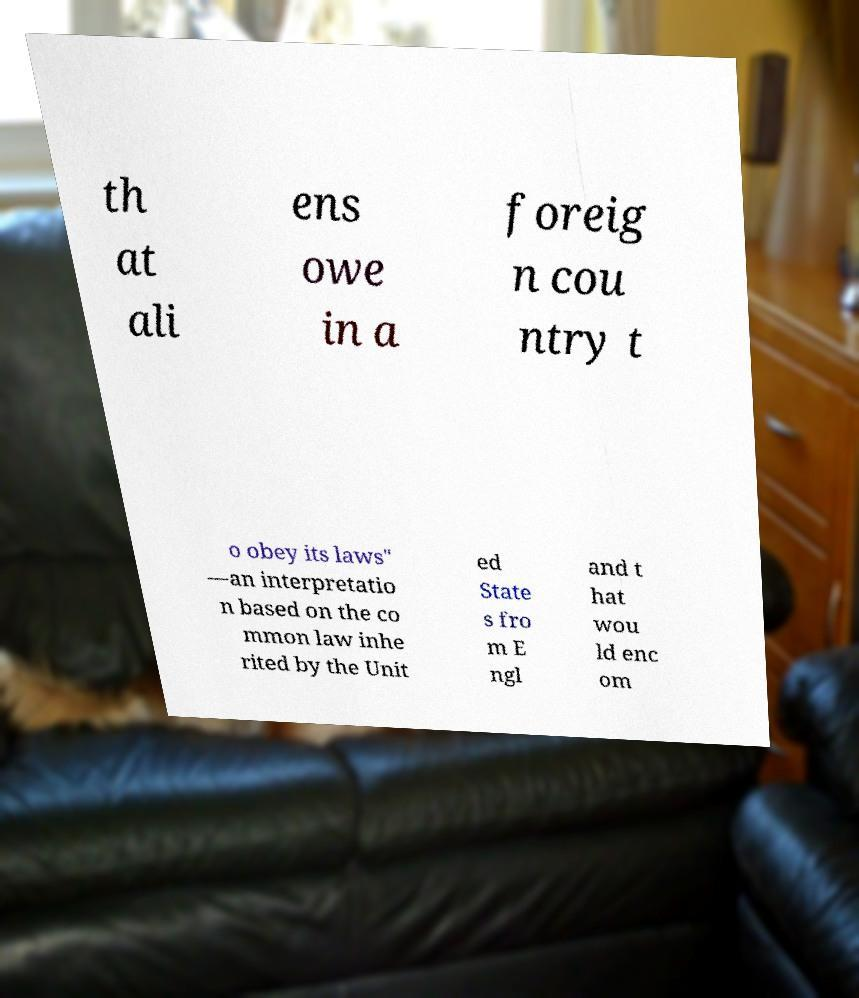Could you extract and type out the text from this image? th at ali ens owe in a foreig n cou ntry t o obey its laws" —an interpretatio n based on the co mmon law inhe rited by the Unit ed State s fro m E ngl and t hat wou ld enc om 